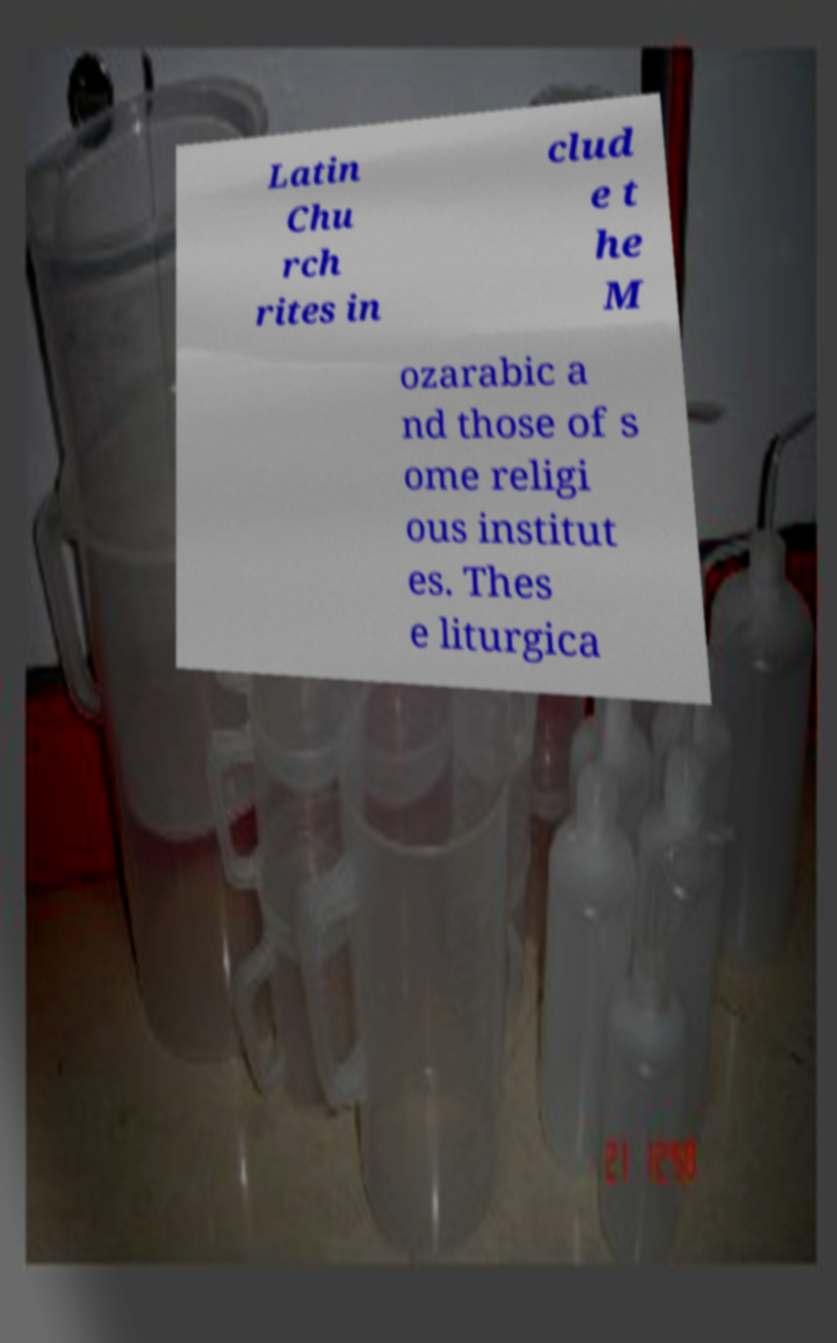Can you accurately transcribe the text from the provided image for me? Latin Chu rch rites in clud e t he M ozarabic a nd those of s ome religi ous institut es. Thes e liturgica 